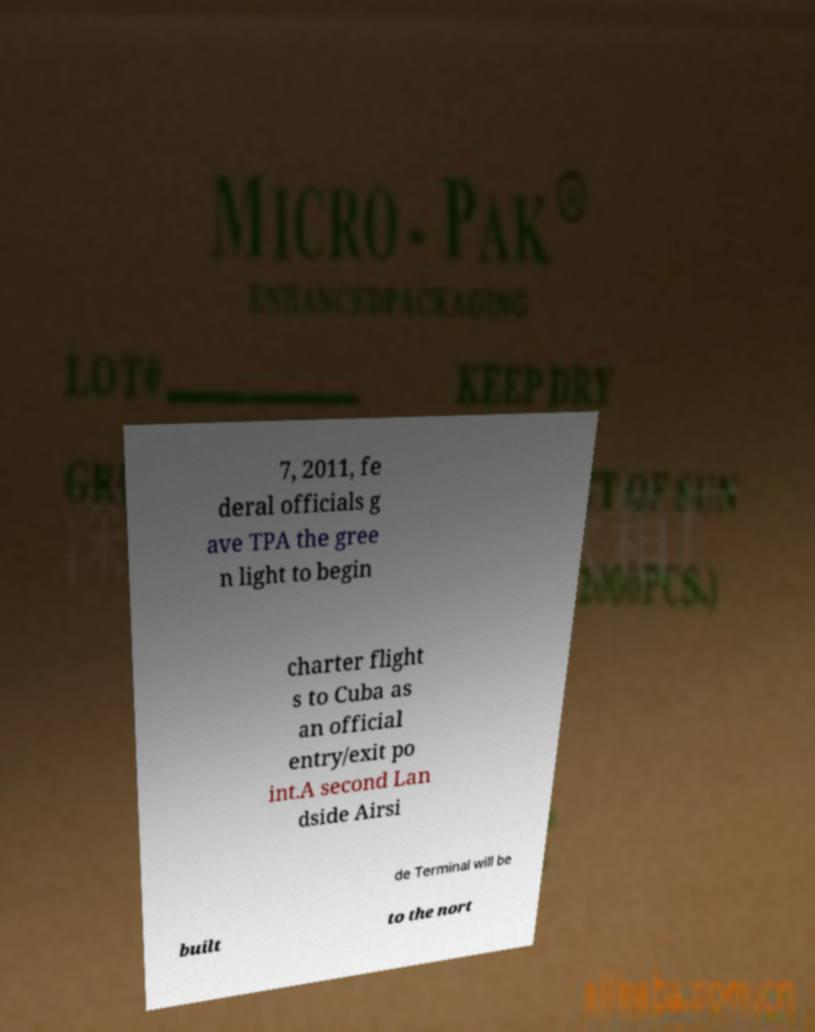Could you extract and type out the text from this image? 7, 2011, fe deral officials g ave TPA the gree n light to begin charter flight s to Cuba as an official entry/exit po int.A second Lan dside Airsi de Terminal will be built to the nort 